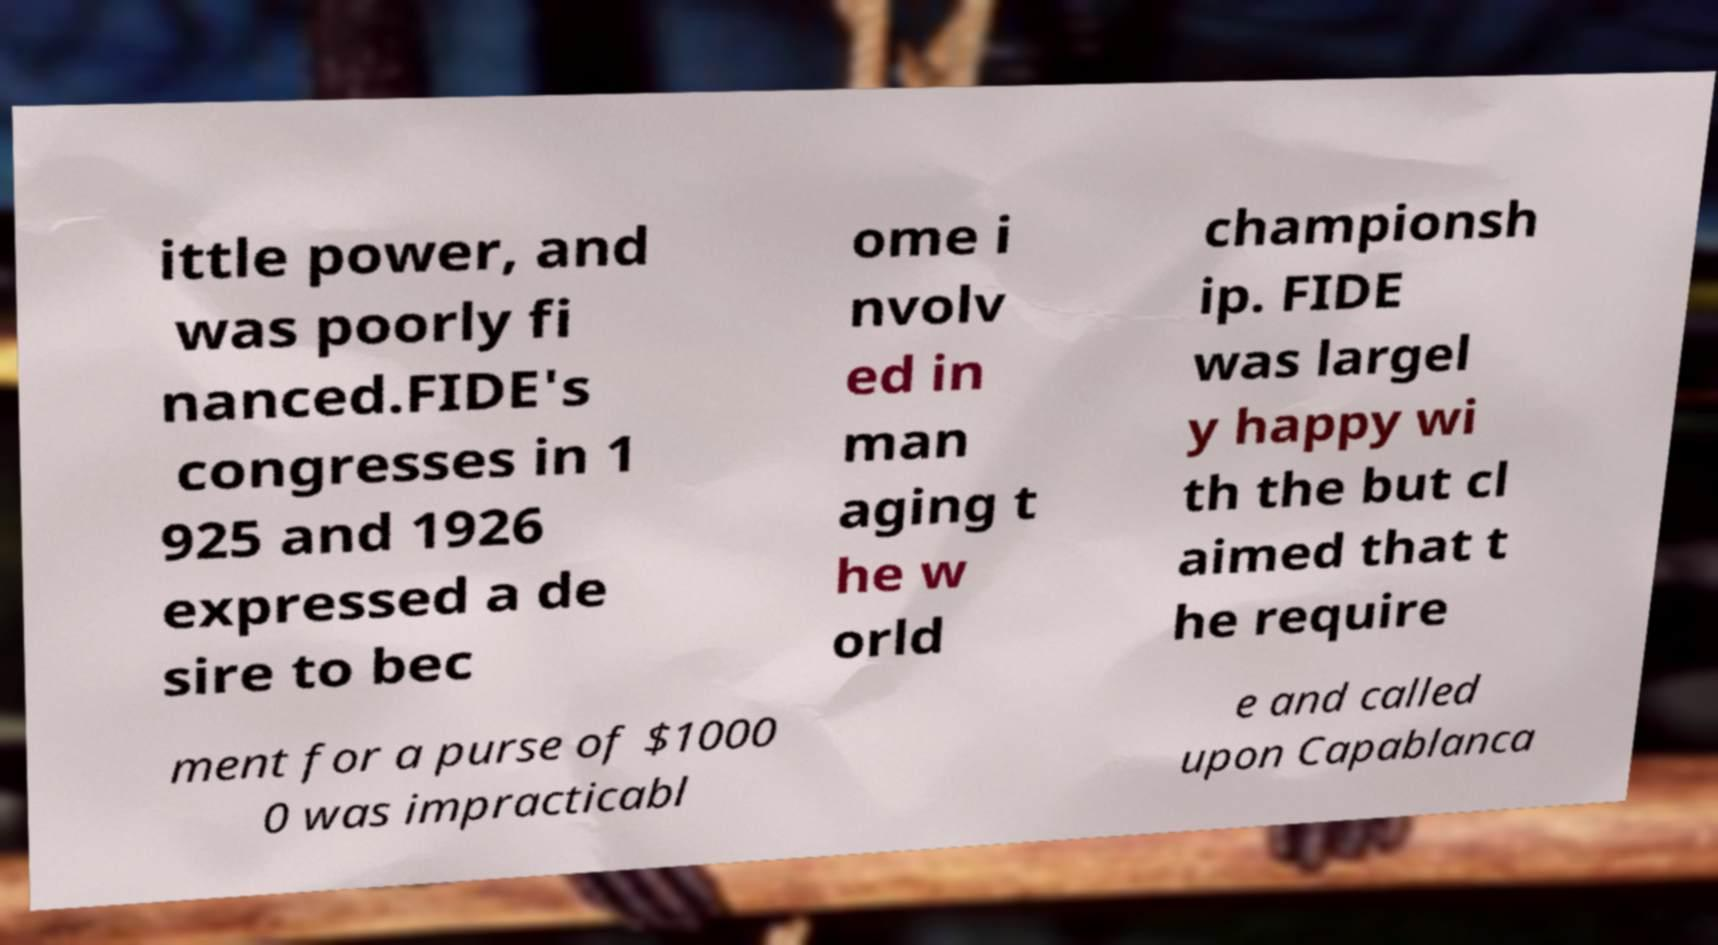For documentation purposes, I need the text within this image transcribed. Could you provide that? ittle power, and was poorly fi nanced.FIDE's congresses in 1 925 and 1926 expressed a de sire to bec ome i nvolv ed in man aging t he w orld championsh ip. FIDE was largel y happy wi th the but cl aimed that t he require ment for a purse of $1000 0 was impracticabl e and called upon Capablanca 